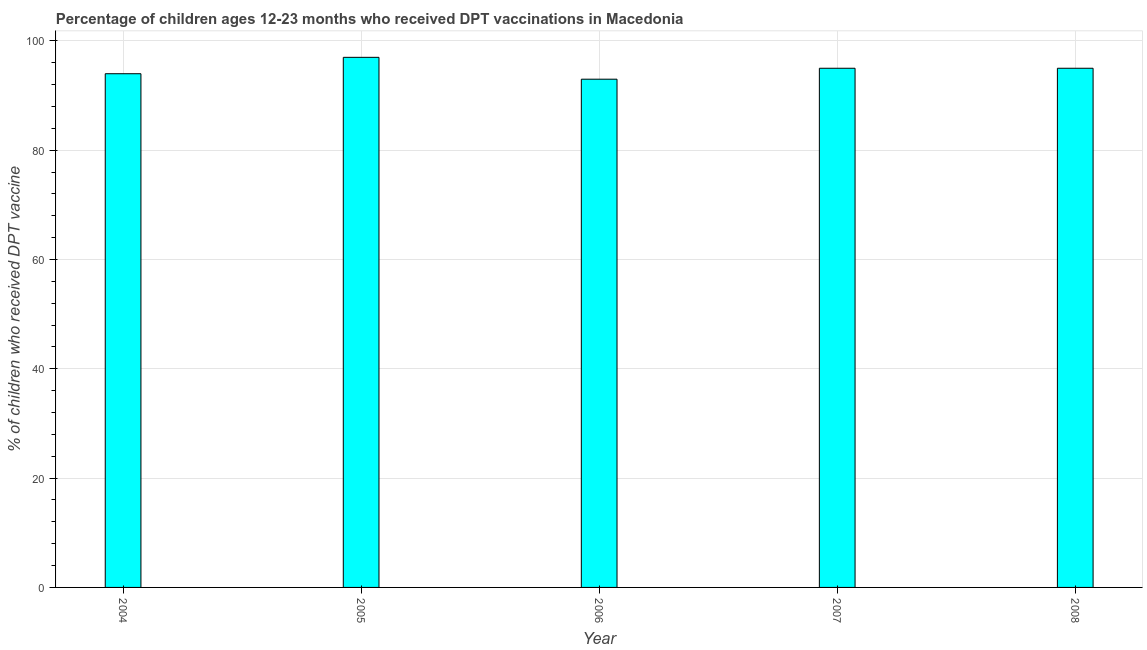Does the graph contain grids?
Your response must be concise. Yes. What is the title of the graph?
Provide a succinct answer. Percentage of children ages 12-23 months who received DPT vaccinations in Macedonia. What is the label or title of the X-axis?
Your answer should be very brief. Year. What is the label or title of the Y-axis?
Make the answer very short. % of children who received DPT vaccine. What is the percentage of children who received dpt vaccine in 2006?
Provide a succinct answer. 93. Across all years, what is the maximum percentage of children who received dpt vaccine?
Provide a succinct answer. 97. Across all years, what is the minimum percentage of children who received dpt vaccine?
Offer a very short reply. 93. In which year was the percentage of children who received dpt vaccine maximum?
Ensure brevity in your answer.  2005. In which year was the percentage of children who received dpt vaccine minimum?
Ensure brevity in your answer.  2006. What is the sum of the percentage of children who received dpt vaccine?
Offer a very short reply. 474. What is the average percentage of children who received dpt vaccine per year?
Give a very brief answer. 94. What is the ratio of the percentage of children who received dpt vaccine in 2005 to that in 2006?
Make the answer very short. 1.04. Is the difference between the percentage of children who received dpt vaccine in 2007 and 2008 greater than the difference between any two years?
Offer a very short reply. No. What is the difference between the highest and the second highest percentage of children who received dpt vaccine?
Ensure brevity in your answer.  2. What is the difference between the highest and the lowest percentage of children who received dpt vaccine?
Provide a short and direct response. 4. In how many years, is the percentage of children who received dpt vaccine greater than the average percentage of children who received dpt vaccine taken over all years?
Provide a succinct answer. 3. Are all the bars in the graph horizontal?
Provide a short and direct response. No. What is the difference between two consecutive major ticks on the Y-axis?
Keep it short and to the point. 20. Are the values on the major ticks of Y-axis written in scientific E-notation?
Your response must be concise. No. What is the % of children who received DPT vaccine in 2004?
Offer a very short reply. 94. What is the % of children who received DPT vaccine of 2005?
Give a very brief answer. 97. What is the % of children who received DPT vaccine of 2006?
Ensure brevity in your answer.  93. What is the % of children who received DPT vaccine of 2007?
Provide a succinct answer. 95. What is the % of children who received DPT vaccine of 2008?
Keep it short and to the point. 95. What is the difference between the % of children who received DPT vaccine in 2004 and 2005?
Provide a succinct answer. -3. What is the difference between the % of children who received DPT vaccine in 2004 and 2006?
Provide a short and direct response. 1. What is the difference between the % of children who received DPT vaccine in 2004 and 2007?
Keep it short and to the point. -1. What is the difference between the % of children who received DPT vaccine in 2005 and 2006?
Give a very brief answer. 4. What is the difference between the % of children who received DPT vaccine in 2005 and 2007?
Provide a short and direct response. 2. What is the difference between the % of children who received DPT vaccine in 2006 and 2007?
Ensure brevity in your answer.  -2. What is the difference between the % of children who received DPT vaccine in 2006 and 2008?
Ensure brevity in your answer.  -2. What is the difference between the % of children who received DPT vaccine in 2007 and 2008?
Offer a terse response. 0. What is the ratio of the % of children who received DPT vaccine in 2005 to that in 2006?
Your answer should be very brief. 1.04. What is the ratio of the % of children who received DPT vaccine in 2005 to that in 2007?
Make the answer very short. 1.02. What is the ratio of the % of children who received DPT vaccine in 2006 to that in 2007?
Offer a terse response. 0.98. 